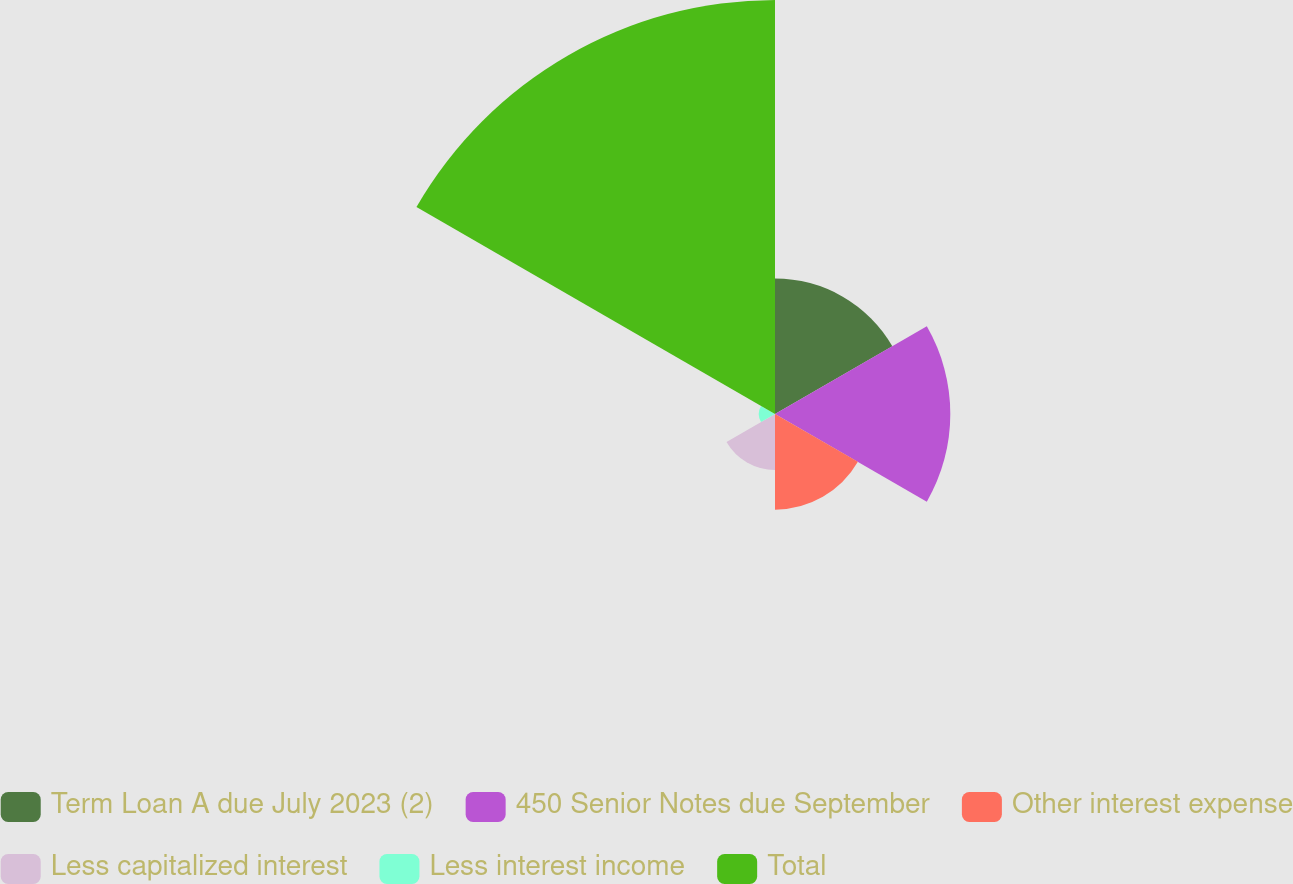Convert chart to OTSL. <chart><loc_0><loc_0><loc_500><loc_500><pie_chart><fcel>Term Loan A due July 2023 (2)<fcel>450 Senior Notes due September<fcel>Other interest expense<fcel>Less capitalized interest<fcel>Less interest income<fcel>Total<nl><fcel>15.18%<fcel>19.64%<fcel>10.72%<fcel>6.27%<fcel>1.81%<fcel>46.38%<nl></chart> 